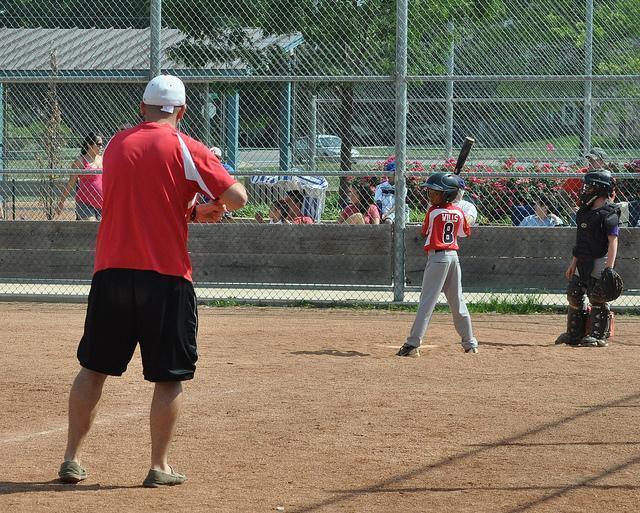What type of field are the kids playing on?
Choose the right answer and clarify with the format: 'Answer: answer
Rationale: rationale.'
Options: Softball, soccer, lacrosse, football. Answer: softball.
Rationale: There is a boy that is ready to swing and he's at the home plate. 